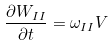<formula> <loc_0><loc_0><loc_500><loc_500>\frac { \partial W _ { I I } } { \partial t } = \omega _ { I I } V</formula> 